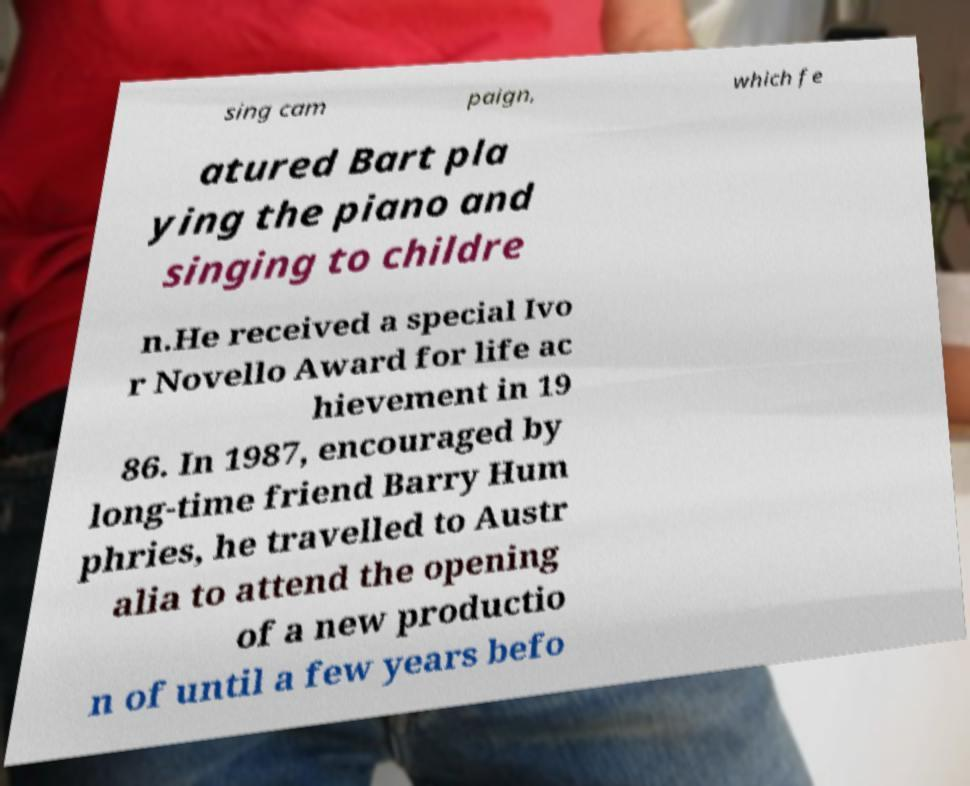For documentation purposes, I need the text within this image transcribed. Could you provide that? sing cam paign, which fe atured Bart pla ying the piano and singing to childre n.He received a special Ivo r Novello Award for life ac hievement in 19 86. In 1987, encouraged by long-time friend Barry Hum phries, he travelled to Austr alia to attend the opening of a new productio n of until a few years befo 